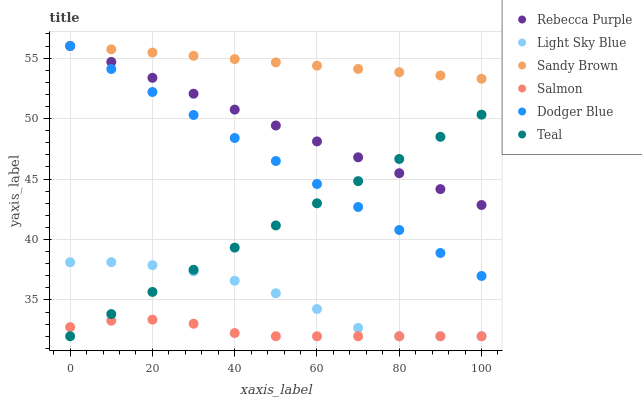Does Salmon have the minimum area under the curve?
Answer yes or no. Yes. Does Sandy Brown have the maximum area under the curve?
Answer yes or no. Yes. Does Light Sky Blue have the minimum area under the curve?
Answer yes or no. No. Does Light Sky Blue have the maximum area under the curve?
Answer yes or no. No. Is Dodger Blue the smoothest?
Answer yes or no. Yes. Is Light Sky Blue the roughest?
Answer yes or no. Yes. Is Light Sky Blue the smoothest?
Answer yes or no. No. Is Dodger Blue the roughest?
Answer yes or no. No. Does Salmon have the lowest value?
Answer yes or no. Yes. Does Dodger Blue have the lowest value?
Answer yes or no. No. Does Sandy Brown have the highest value?
Answer yes or no. Yes. Does Light Sky Blue have the highest value?
Answer yes or no. No. Is Light Sky Blue less than Rebecca Purple?
Answer yes or no. Yes. Is Dodger Blue greater than Salmon?
Answer yes or no. Yes. Does Teal intersect Rebecca Purple?
Answer yes or no. Yes. Is Teal less than Rebecca Purple?
Answer yes or no. No. Is Teal greater than Rebecca Purple?
Answer yes or no. No. Does Light Sky Blue intersect Rebecca Purple?
Answer yes or no. No. 